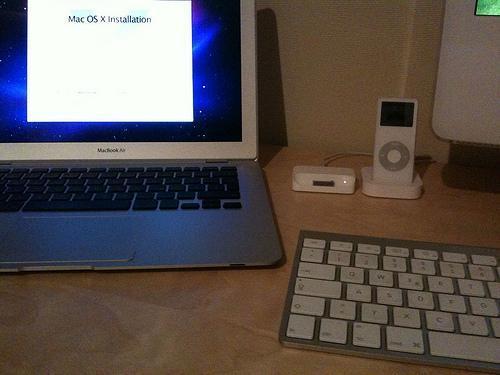How many electronic devices are in the image?
Give a very brief answer. 2. How many laptops are in the picture?
Give a very brief answer. 1. How many keyboards on the in the picture?
Give a very brief answer. 2. 